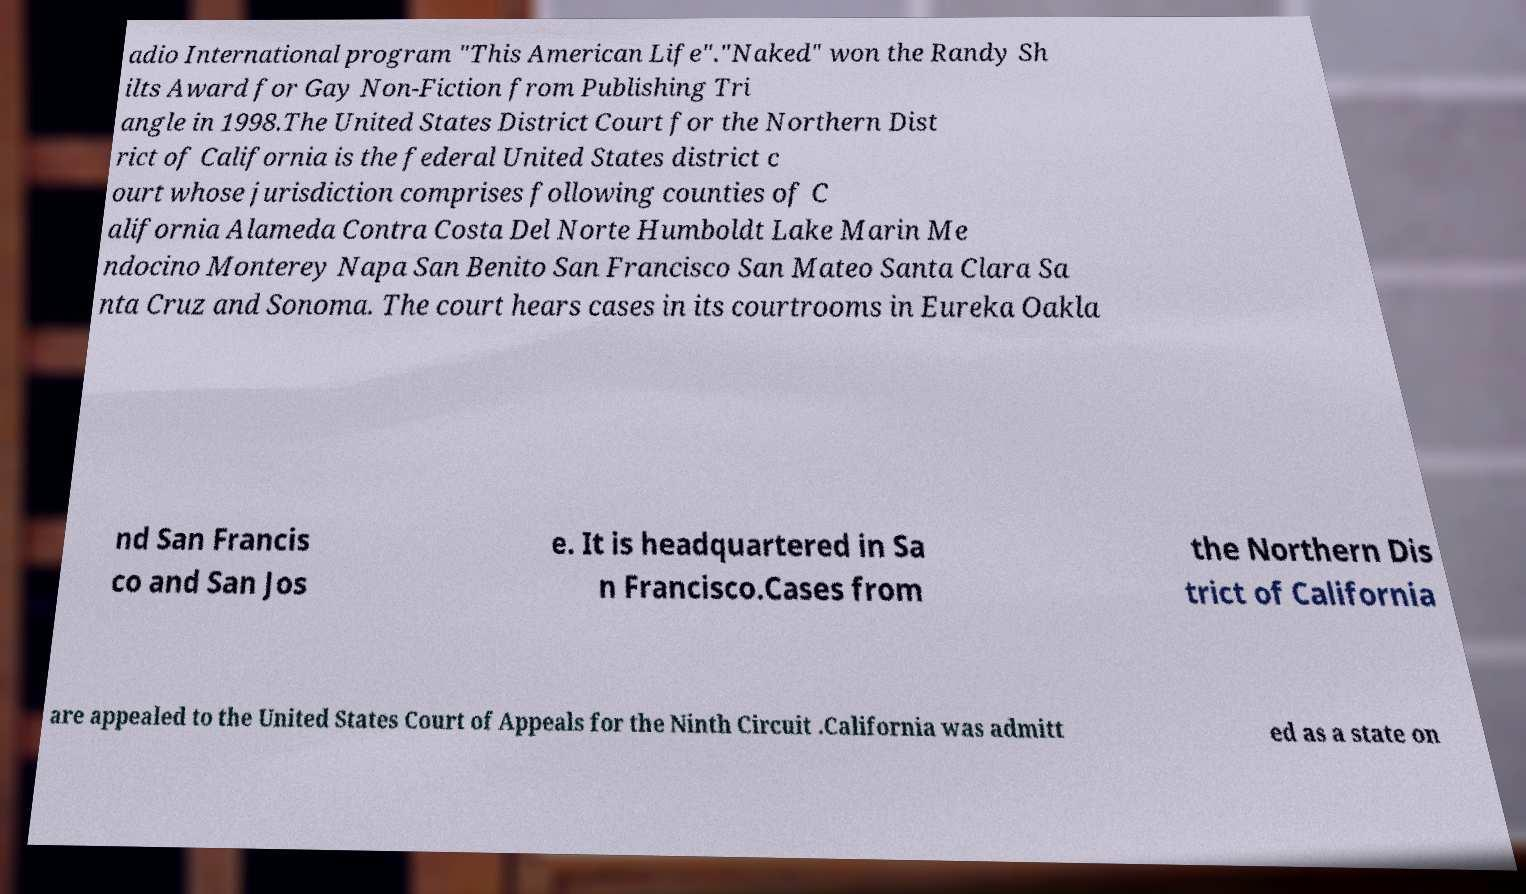For documentation purposes, I need the text within this image transcribed. Could you provide that? adio International program "This American Life"."Naked" won the Randy Sh ilts Award for Gay Non-Fiction from Publishing Tri angle in 1998.The United States District Court for the Northern Dist rict of California is the federal United States district c ourt whose jurisdiction comprises following counties of C alifornia Alameda Contra Costa Del Norte Humboldt Lake Marin Me ndocino Monterey Napa San Benito San Francisco San Mateo Santa Clara Sa nta Cruz and Sonoma. The court hears cases in its courtrooms in Eureka Oakla nd San Francis co and San Jos e. It is headquartered in Sa n Francisco.Cases from the Northern Dis trict of California are appealed to the United States Court of Appeals for the Ninth Circuit .California was admitt ed as a state on 